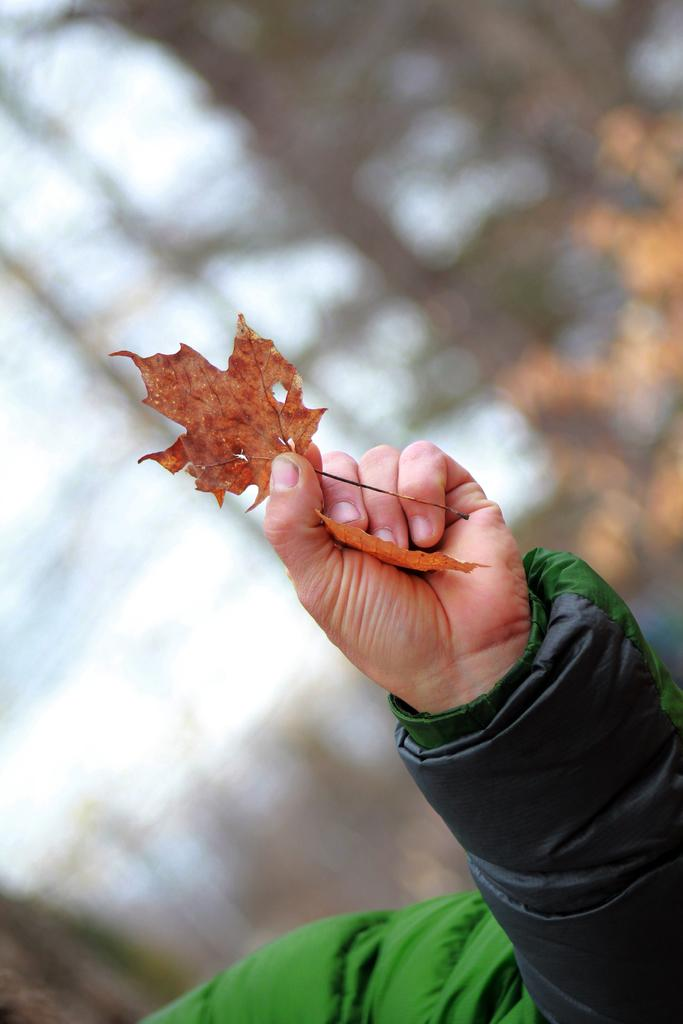What is the main subject of the image? There is a hand in the image. What is the hand holding? The hand is holding leaves. Can you describe the background of the image? The background of the image is blurred. What type of badge is visible on the floor in the image? There is no badge present in the image, and the floor is not visible in the provided facts. 